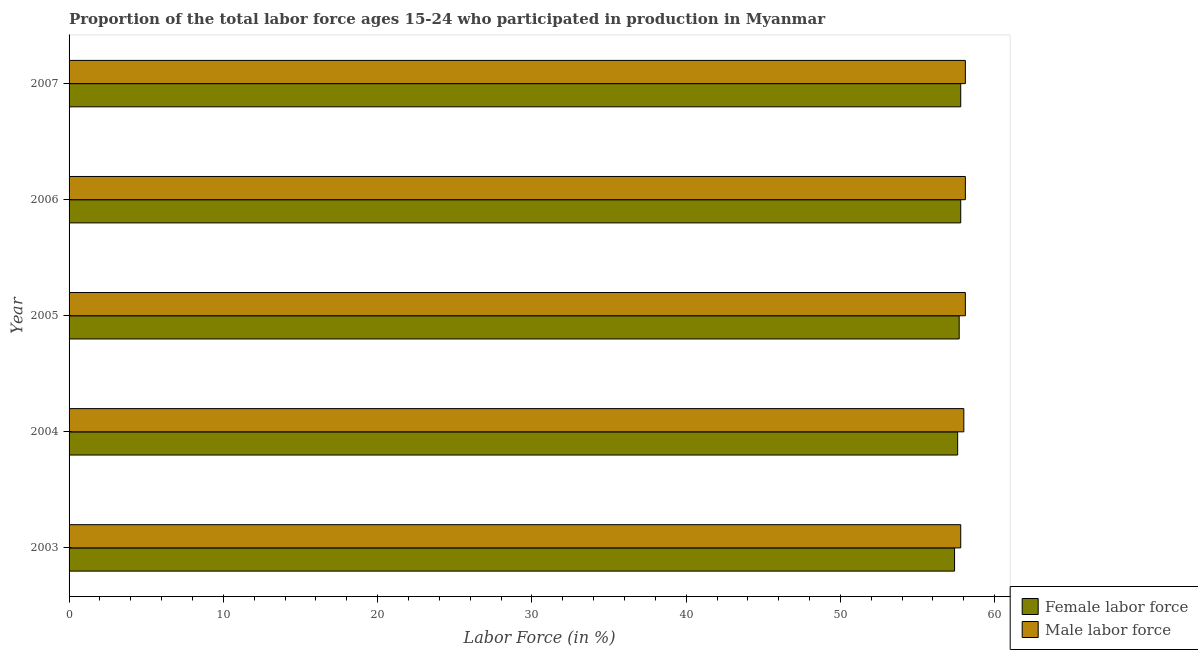How many different coloured bars are there?
Your answer should be compact. 2. How many groups of bars are there?
Make the answer very short. 5. Are the number of bars on each tick of the Y-axis equal?
Ensure brevity in your answer.  Yes. How many bars are there on the 4th tick from the top?
Your answer should be very brief. 2. How many bars are there on the 2nd tick from the bottom?
Keep it short and to the point. 2. What is the label of the 3rd group of bars from the top?
Provide a short and direct response. 2005. Across all years, what is the maximum percentage of male labour force?
Your answer should be very brief. 58.1. Across all years, what is the minimum percentage of male labour force?
Your response must be concise. 57.8. In which year was the percentage of male labour force minimum?
Give a very brief answer. 2003. What is the total percentage of male labour force in the graph?
Offer a very short reply. 290.1. What is the difference between the percentage of male labour force in 2006 and the percentage of female labor force in 2003?
Provide a short and direct response. 0.7. What is the average percentage of male labour force per year?
Keep it short and to the point. 58.02. In the year 2003, what is the difference between the percentage of female labor force and percentage of male labour force?
Give a very brief answer. -0.4. What is the ratio of the percentage of male labour force in 2003 to that in 2006?
Give a very brief answer. 0.99. Is the difference between the percentage of female labor force in 2003 and 2006 greater than the difference between the percentage of male labour force in 2003 and 2006?
Your answer should be compact. No. What is the difference between the highest and the second highest percentage of female labor force?
Give a very brief answer. 0. What is the difference between the highest and the lowest percentage of male labour force?
Your response must be concise. 0.3. In how many years, is the percentage of male labour force greater than the average percentage of male labour force taken over all years?
Give a very brief answer. 3. What does the 2nd bar from the top in 2006 represents?
Provide a short and direct response. Female labor force. What does the 1st bar from the bottom in 2003 represents?
Provide a succinct answer. Female labor force. How many bars are there?
Provide a succinct answer. 10. What is the difference between two consecutive major ticks on the X-axis?
Give a very brief answer. 10. Does the graph contain grids?
Provide a short and direct response. No. How are the legend labels stacked?
Ensure brevity in your answer.  Vertical. What is the title of the graph?
Keep it short and to the point. Proportion of the total labor force ages 15-24 who participated in production in Myanmar. What is the label or title of the X-axis?
Provide a short and direct response. Labor Force (in %). What is the Labor Force (in %) of Female labor force in 2003?
Provide a succinct answer. 57.4. What is the Labor Force (in %) of Male labor force in 2003?
Your response must be concise. 57.8. What is the Labor Force (in %) of Female labor force in 2004?
Your answer should be very brief. 57.6. What is the Labor Force (in %) of Male labor force in 2004?
Give a very brief answer. 58. What is the Labor Force (in %) in Female labor force in 2005?
Ensure brevity in your answer.  57.7. What is the Labor Force (in %) of Male labor force in 2005?
Your answer should be compact. 58.1. What is the Labor Force (in %) in Female labor force in 2006?
Give a very brief answer. 57.8. What is the Labor Force (in %) in Male labor force in 2006?
Give a very brief answer. 58.1. What is the Labor Force (in %) of Female labor force in 2007?
Your response must be concise. 57.8. What is the Labor Force (in %) of Male labor force in 2007?
Your answer should be compact. 58.1. Across all years, what is the maximum Labor Force (in %) of Female labor force?
Offer a terse response. 57.8. Across all years, what is the maximum Labor Force (in %) of Male labor force?
Provide a short and direct response. 58.1. Across all years, what is the minimum Labor Force (in %) of Female labor force?
Your answer should be compact. 57.4. Across all years, what is the minimum Labor Force (in %) in Male labor force?
Your response must be concise. 57.8. What is the total Labor Force (in %) of Female labor force in the graph?
Provide a succinct answer. 288.3. What is the total Labor Force (in %) in Male labor force in the graph?
Keep it short and to the point. 290.1. What is the difference between the Labor Force (in %) in Female labor force in 2003 and that in 2004?
Your answer should be compact. -0.2. What is the difference between the Labor Force (in %) in Male labor force in 2003 and that in 2004?
Offer a very short reply. -0.2. What is the difference between the Labor Force (in %) of Male labor force in 2003 and that in 2005?
Offer a terse response. -0.3. What is the difference between the Labor Force (in %) of Female labor force in 2003 and that in 2006?
Offer a terse response. -0.4. What is the difference between the Labor Force (in %) of Male labor force in 2004 and that in 2005?
Offer a very short reply. -0.1. What is the difference between the Labor Force (in %) of Female labor force in 2004 and that in 2007?
Keep it short and to the point. -0.2. What is the difference between the Labor Force (in %) in Male labor force in 2004 and that in 2007?
Ensure brevity in your answer.  -0.1. What is the difference between the Labor Force (in %) of Female labor force in 2005 and that in 2006?
Provide a short and direct response. -0.1. What is the difference between the Labor Force (in %) in Male labor force in 2005 and that in 2006?
Your answer should be very brief. 0. What is the difference between the Labor Force (in %) in Female labor force in 2005 and that in 2007?
Your response must be concise. -0.1. What is the difference between the Labor Force (in %) in Male labor force in 2006 and that in 2007?
Make the answer very short. 0. What is the difference between the Labor Force (in %) in Female labor force in 2003 and the Labor Force (in %) in Male labor force in 2005?
Your answer should be very brief. -0.7. What is the difference between the Labor Force (in %) in Female labor force in 2003 and the Labor Force (in %) in Male labor force in 2006?
Your response must be concise. -0.7. What is the difference between the Labor Force (in %) in Female labor force in 2004 and the Labor Force (in %) in Male labor force in 2005?
Ensure brevity in your answer.  -0.5. What is the difference between the Labor Force (in %) in Female labor force in 2004 and the Labor Force (in %) in Male labor force in 2006?
Give a very brief answer. -0.5. What is the difference between the Labor Force (in %) of Female labor force in 2004 and the Labor Force (in %) of Male labor force in 2007?
Keep it short and to the point. -0.5. What is the difference between the Labor Force (in %) in Female labor force in 2005 and the Labor Force (in %) in Male labor force in 2007?
Your answer should be compact. -0.4. What is the difference between the Labor Force (in %) in Female labor force in 2006 and the Labor Force (in %) in Male labor force in 2007?
Offer a very short reply. -0.3. What is the average Labor Force (in %) in Female labor force per year?
Ensure brevity in your answer.  57.66. What is the average Labor Force (in %) in Male labor force per year?
Offer a terse response. 58.02. In the year 2003, what is the difference between the Labor Force (in %) of Female labor force and Labor Force (in %) of Male labor force?
Provide a succinct answer. -0.4. What is the ratio of the Labor Force (in %) of Female labor force in 2003 to that in 2004?
Your answer should be very brief. 1. What is the ratio of the Labor Force (in %) in Male labor force in 2003 to that in 2004?
Keep it short and to the point. 1. What is the ratio of the Labor Force (in %) in Female labor force in 2003 to that in 2005?
Make the answer very short. 0.99. What is the ratio of the Labor Force (in %) of Male labor force in 2003 to that in 2006?
Offer a very short reply. 0.99. What is the ratio of the Labor Force (in %) of Female labor force in 2003 to that in 2007?
Ensure brevity in your answer.  0.99. What is the ratio of the Labor Force (in %) of Male labor force in 2003 to that in 2007?
Your answer should be very brief. 0.99. What is the ratio of the Labor Force (in %) in Female labor force in 2004 to that in 2005?
Provide a succinct answer. 1. What is the ratio of the Labor Force (in %) of Male labor force in 2004 to that in 2005?
Offer a terse response. 1. What is the ratio of the Labor Force (in %) in Female labor force in 2004 to that in 2006?
Make the answer very short. 1. What is the ratio of the Labor Force (in %) in Male labor force in 2005 to that in 2006?
Ensure brevity in your answer.  1. What is the ratio of the Labor Force (in %) in Female labor force in 2005 to that in 2007?
Make the answer very short. 1. What is the ratio of the Labor Force (in %) in Male labor force in 2005 to that in 2007?
Ensure brevity in your answer.  1. What is the ratio of the Labor Force (in %) of Female labor force in 2006 to that in 2007?
Provide a succinct answer. 1. What is the ratio of the Labor Force (in %) of Male labor force in 2006 to that in 2007?
Provide a succinct answer. 1. What is the difference between the highest and the second highest Labor Force (in %) in Female labor force?
Provide a succinct answer. 0. What is the difference between the highest and the second highest Labor Force (in %) of Male labor force?
Provide a succinct answer. 0. 